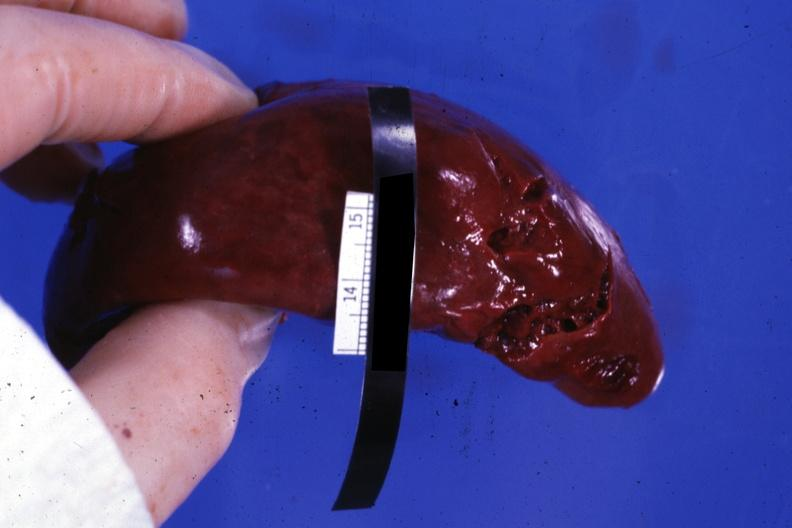s amyloid angiopathy r. endocrine present?
Answer the question using a single word or phrase. No 